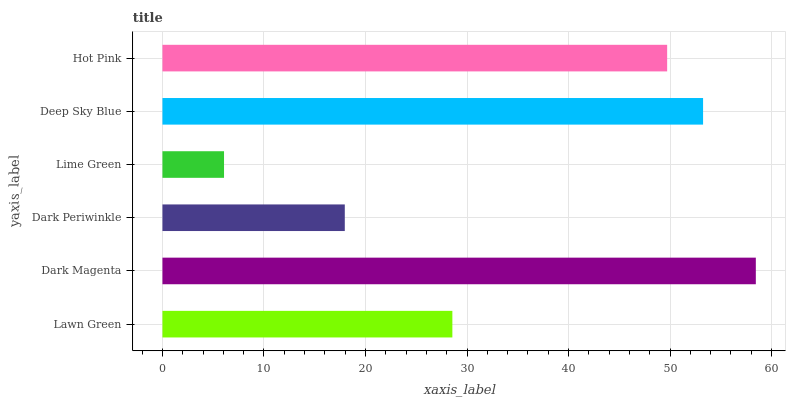Is Lime Green the minimum?
Answer yes or no. Yes. Is Dark Magenta the maximum?
Answer yes or no. Yes. Is Dark Periwinkle the minimum?
Answer yes or no. No. Is Dark Periwinkle the maximum?
Answer yes or no. No. Is Dark Magenta greater than Dark Periwinkle?
Answer yes or no. Yes. Is Dark Periwinkle less than Dark Magenta?
Answer yes or no. Yes. Is Dark Periwinkle greater than Dark Magenta?
Answer yes or no. No. Is Dark Magenta less than Dark Periwinkle?
Answer yes or no. No. Is Hot Pink the high median?
Answer yes or no. Yes. Is Lawn Green the low median?
Answer yes or no. Yes. Is Dark Magenta the high median?
Answer yes or no. No. Is Dark Magenta the low median?
Answer yes or no. No. 